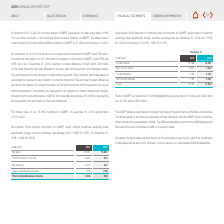According to Asm International Nv's financial document, What is the ASMPT Board responsible for?  ongoing monitoring of the performance of the Back-end activities. The document states: "The ASMPT Board is responsible for ongoing monitoring of the performance of the Back-end activities...." Also, What are the years included in the table? The document shows two values: 2018 and 2019. From the document: "(HK$ million) 2018 2019 (HK$ million) 2018 2019..." Also, What is the current assets in 2018? According to the financial document, 15,168 (in millions). The relevant text states: "Current assets 15,168 13,381..." Also, can you calculate: What is the current liability to current assets ratio for 2019? Based on the calculation:  4,432 / 13,381 , the result is 0.33. This is based on the information: "Current assets 15,168 13,381 Current liabilities 7,792 4,432..." The key data points involved are: 13,381, 4,432. Also, can you calculate: What is the change in current liability to current assets ratio from 2018 to 2019? To answer this question, I need to perform calculations using the financial data. The calculation is:  (4,432 / 13,381)-(7,792/ 15,168) , which equals -0.18. This is based on the information: "Current liabilities 7,792 4,432 Current assets 15,168 13,381 Current assets 15,168 13,381 Current liabilities 7,792 4,432..." The key data points involved are: 13,381, 15,168, 4,432. Additionally, Which year has the highest equity to total asset ratio? According to the financial document, 2018. The relevant text states: "(HK$ million) 2018 2019..." 